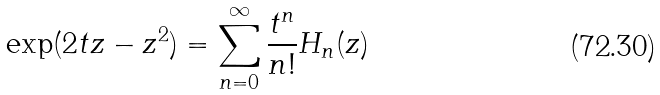Convert formula to latex. <formula><loc_0><loc_0><loc_500><loc_500>\exp ( 2 t z - z ^ { 2 } ) = \sum _ { n = 0 } ^ { \infty } \frac { t ^ { n } } { n ! } H _ { n } ( z )</formula> 